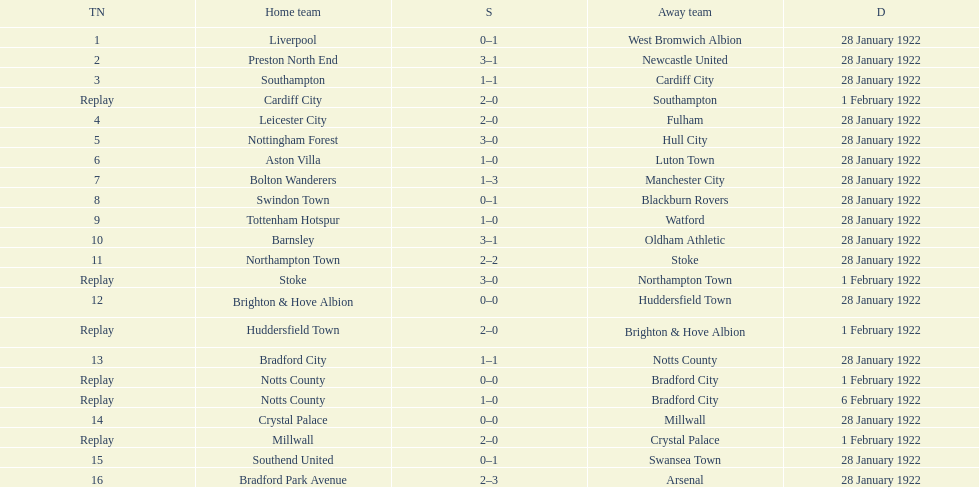How many games had four total points scored or more? 5. 